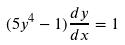<formula> <loc_0><loc_0><loc_500><loc_500>( 5 y ^ { 4 } - 1 ) \frac { d y } { d x } = 1</formula> 